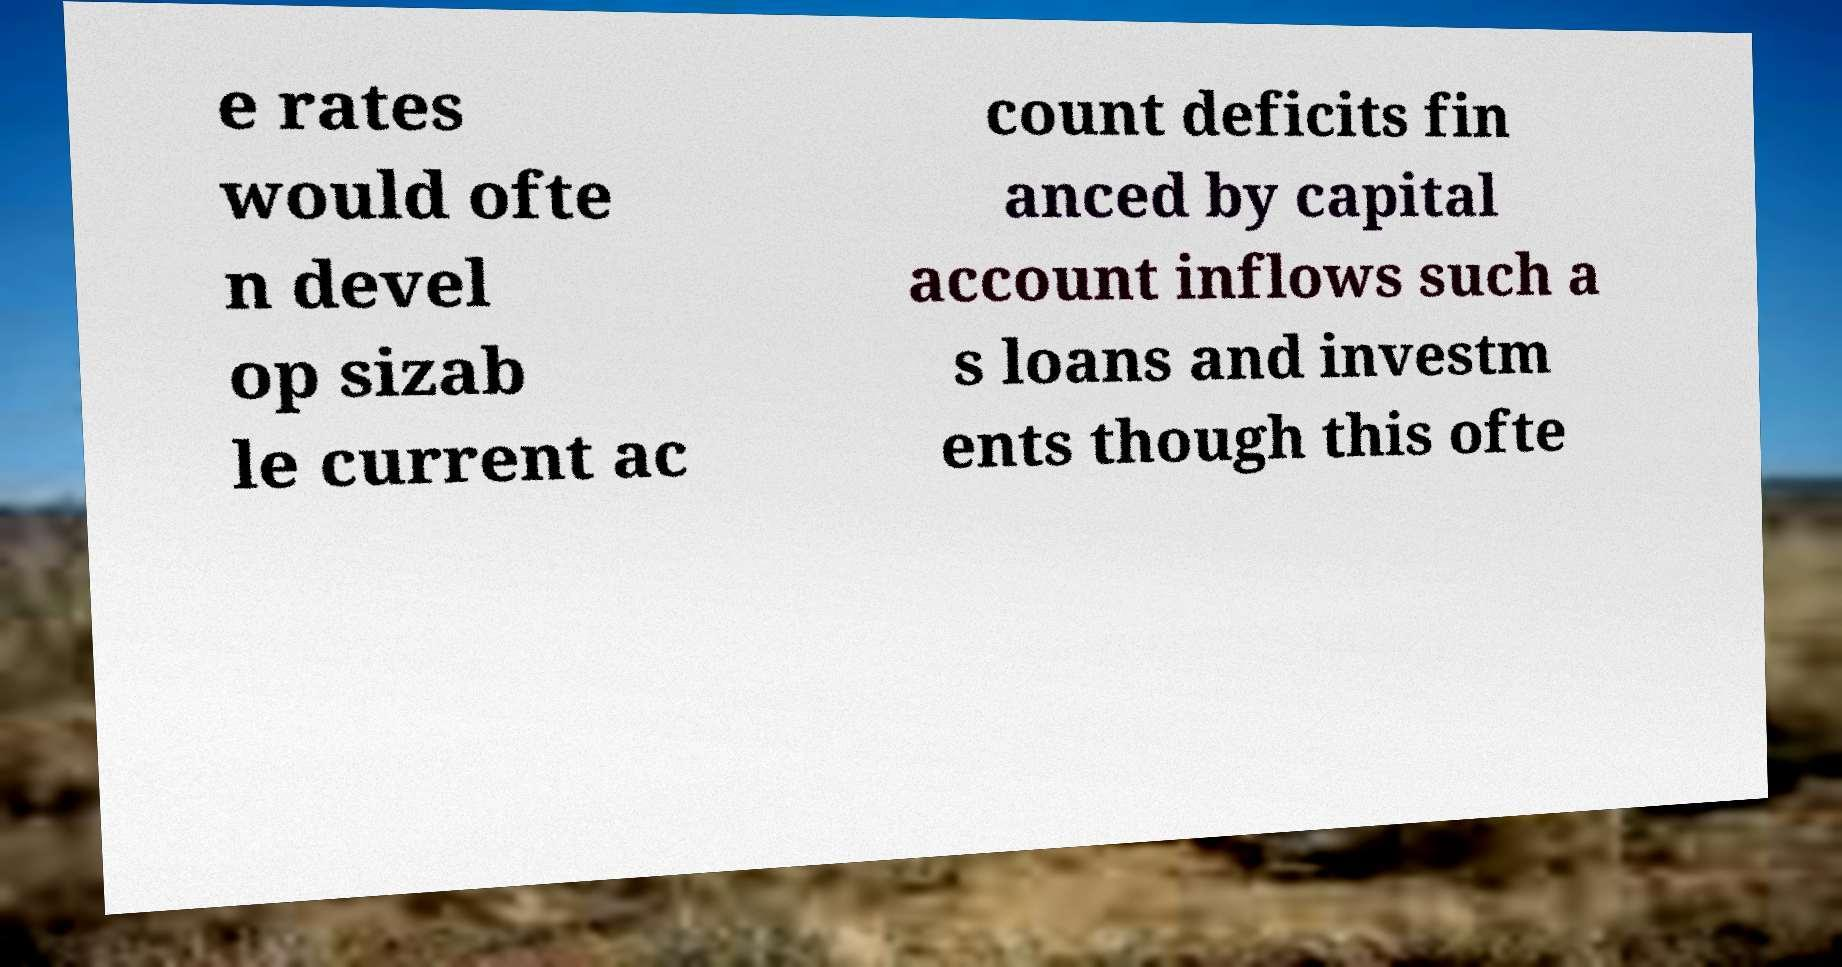Could you assist in decoding the text presented in this image and type it out clearly? e rates would ofte n devel op sizab le current ac count deficits fin anced by capital account inflows such a s loans and investm ents though this ofte 